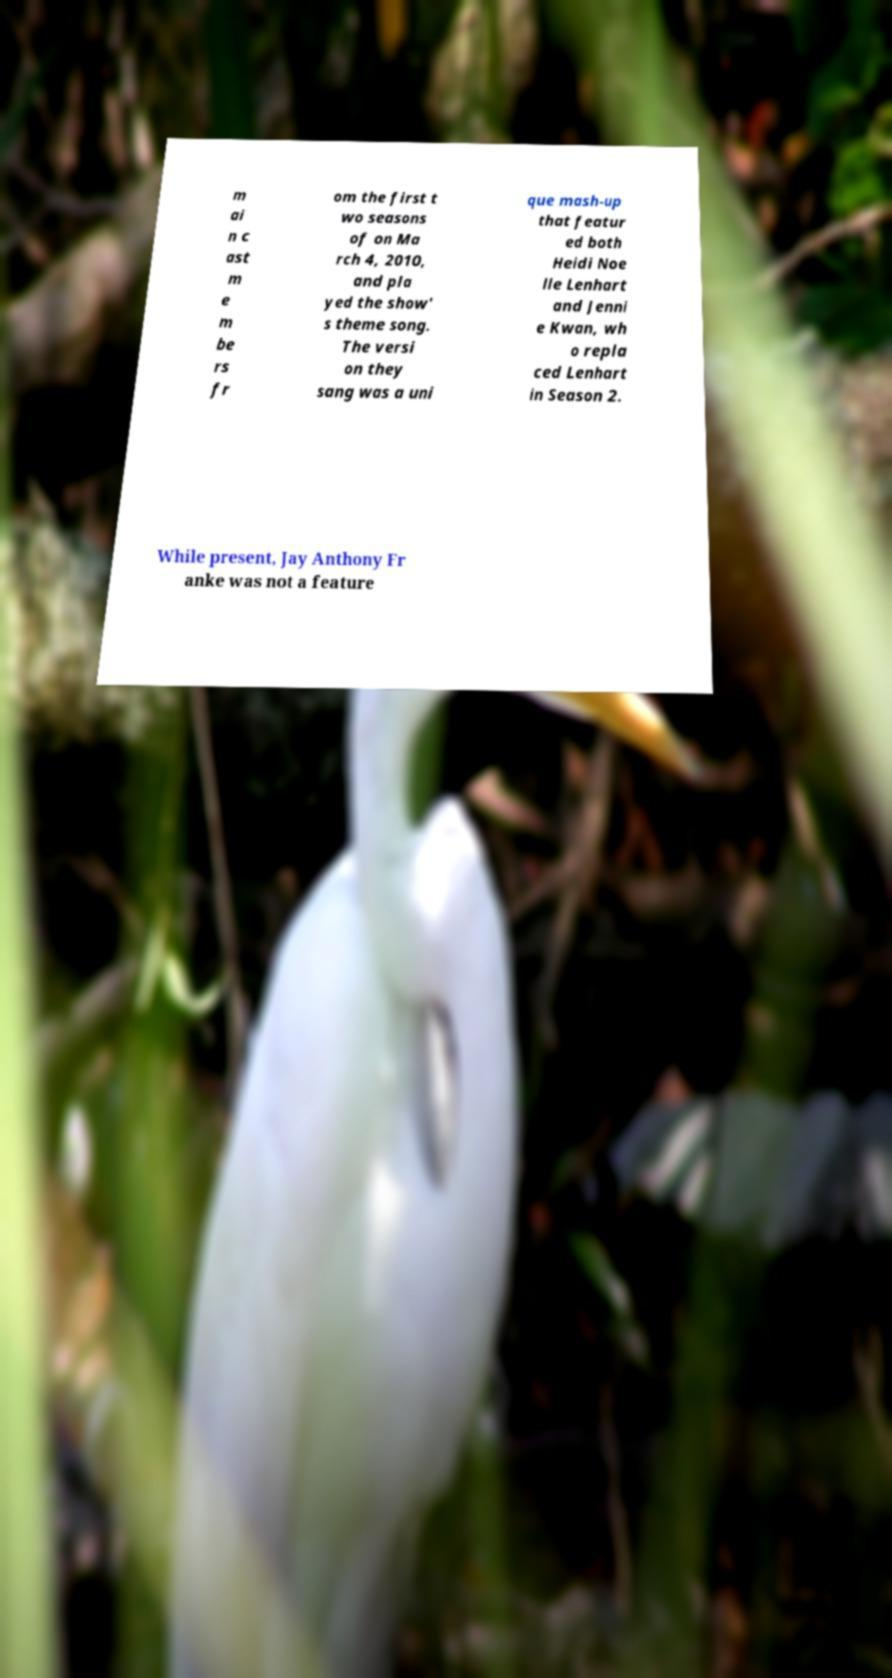Can you accurately transcribe the text from the provided image for me? m ai n c ast m e m be rs fr om the first t wo seasons of on Ma rch 4, 2010, and pla yed the show' s theme song. The versi on they sang was a uni que mash-up that featur ed both Heidi Noe lle Lenhart and Jenni e Kwan, wh o repla ced Lenhart in Season 2. While present, Jay Anthony Fr anke was not a feature 